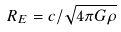Convert formula to latex. <formula><loc_0><loc_0><loc_500><loc_500>R _ { E } = c / \sqrt { 4 \pi G \rho }</formula> 